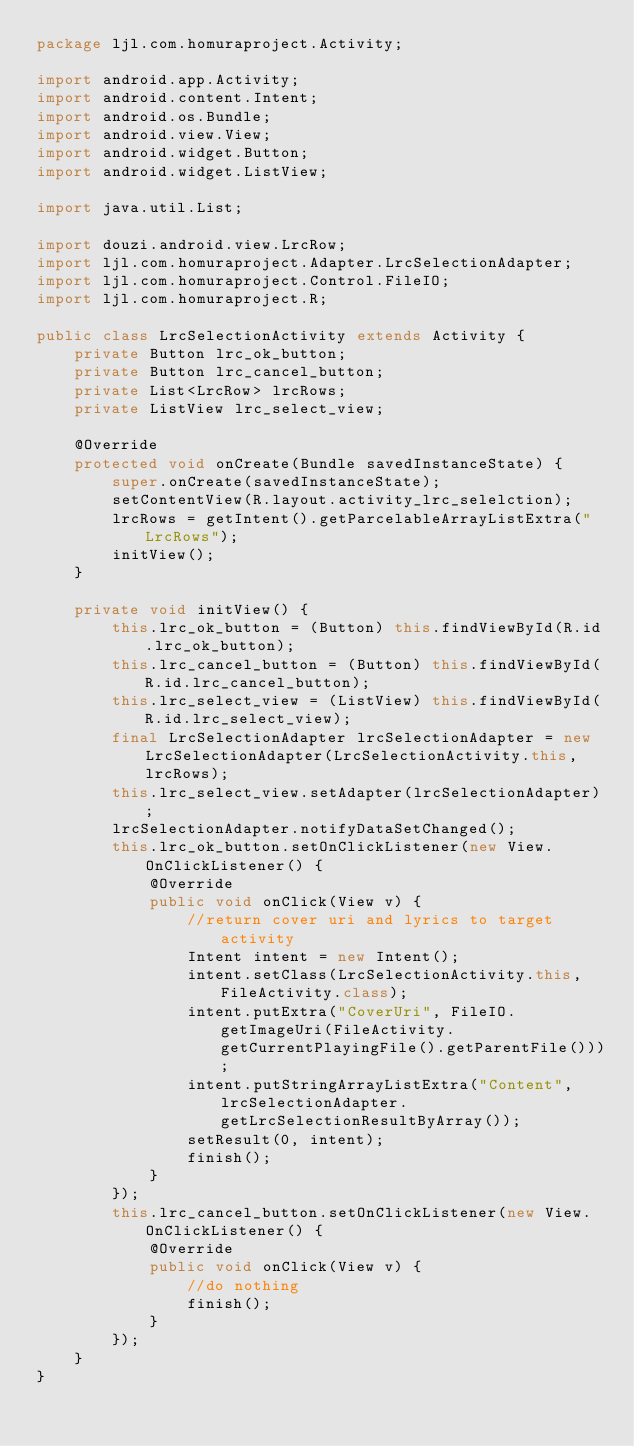Convert code to text. <code><loc_0><loc_0><loc_500><loc_500><_Java_>package ljl.com.homuraproject.Activity;

import android.app.Activity;
import android.content.Intent;
import android.os.Bundle;
import android.view.View;
import android.widget.Button;
import android.widget.ListView;

import java.util.List;

import douzi.android.view.LrcRow;
import ljl.com.homuraproject.Adapter.LrcSelectionAdapter;
import ljl.com.homuraproject.Control.FileIO;
import ljl.com.homuraproject.R;

public class LrcSelectionActivity extends Activity {
    private Button lrc_ok_button;
    private Button lrc_cancel_button;
    private List<LrcRow> lrcRows;
    private ListView lrc_select_view;

    @Override
    protected void onCreate(Bundle savedInstanceState) {
        super.onCreate(savedInstanceState);
        setContentView(R.layout.activity_lrc_selelction);
        lrcRows = getIntent().getParcelableArrayListExtra("LrcRows");
        initView();
    }

    private void initView() {
        this.lrc_ok_button = (Button) this.findViewById(R.id.lrc_ok_button);
        this.lrc_cancel_button = (Button) this.findViewById(R.id.lrc_cancel_button);
        this.lrc_select_view = (ListView) this.findViewById(R.id.lrc_select_view);
        final LrcSelectionAdapter lrcSelectionAdapter = new LrcSelectionAdapter(LrcSelectionActivity.this, lrcRows);
        this.lrc_select_view.setAdapter(lrcSelectionAdapter);
        lrcSelectionAdapter.notifyDataSetChanged();
        this.lrc_ok_button.setOnClickListener(new View.OnClickListener() {
            @Override
            public void onClick(View v) {
                //return cover uri and lyrics to target activity
                Intent intent = new Intent();
                intent.setClass(LrcSelectionActivity.this, FileActivity.class);
                intent.putExtra("CoverUri", FileIO.getImageUri(FileActivity.getCurrentPlayingFile().getParentFile()));
                intent.putStringArrayListExtra("Content", lrcSelectionAdapter.getLrcSelectionResultByArray());
                setResult(0, intent);
                finish();
            }
        });
        this.lrc_cancel_button.setOnClickListener(new View.OnClickListener() {
            @Override
            public void onClick(View v) {
                //do nothing
                finish();
            }
        });
    }
}
</code> 